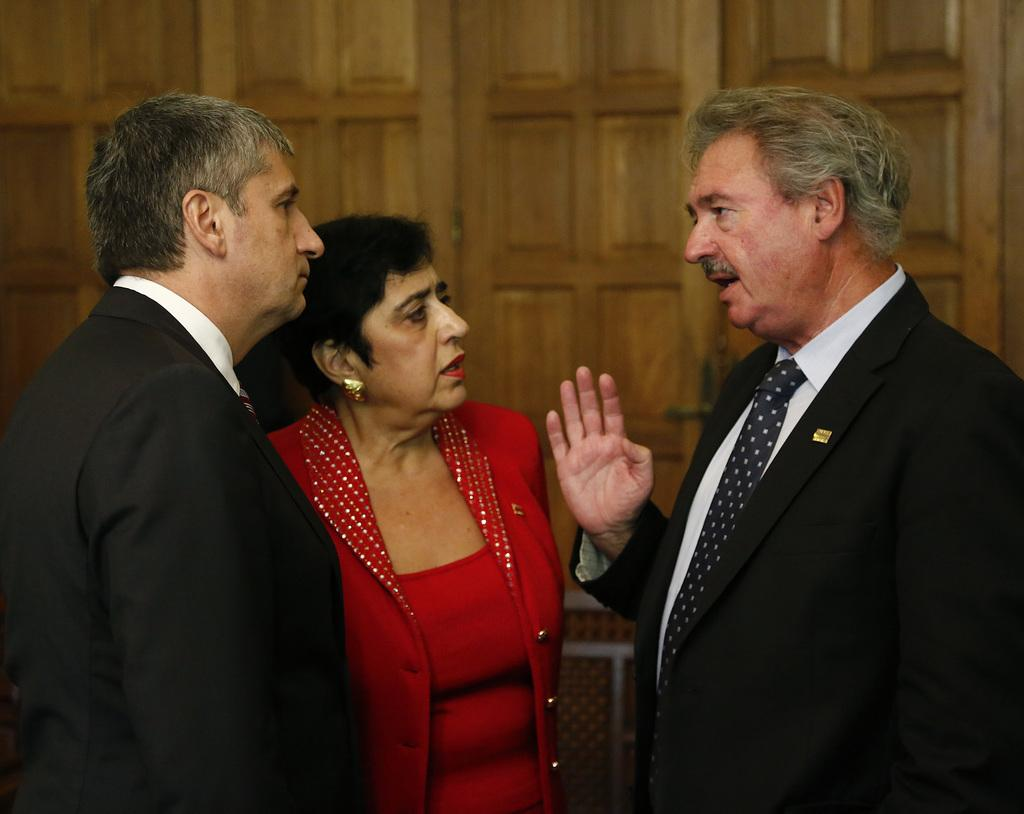How many people are present in the image? There are three individuals in the image: two men and a woman. What are the people in the image doing? The three individuals are standing. What can be seen in the background of the image? There is a wooden wall in the background of the image. What type of honey is being served at the feast in the image? There is no feast or honey present in the image; it features three individuals standing in front of a wooden wall. What is the net used for in the image? There is no net present in the image. 